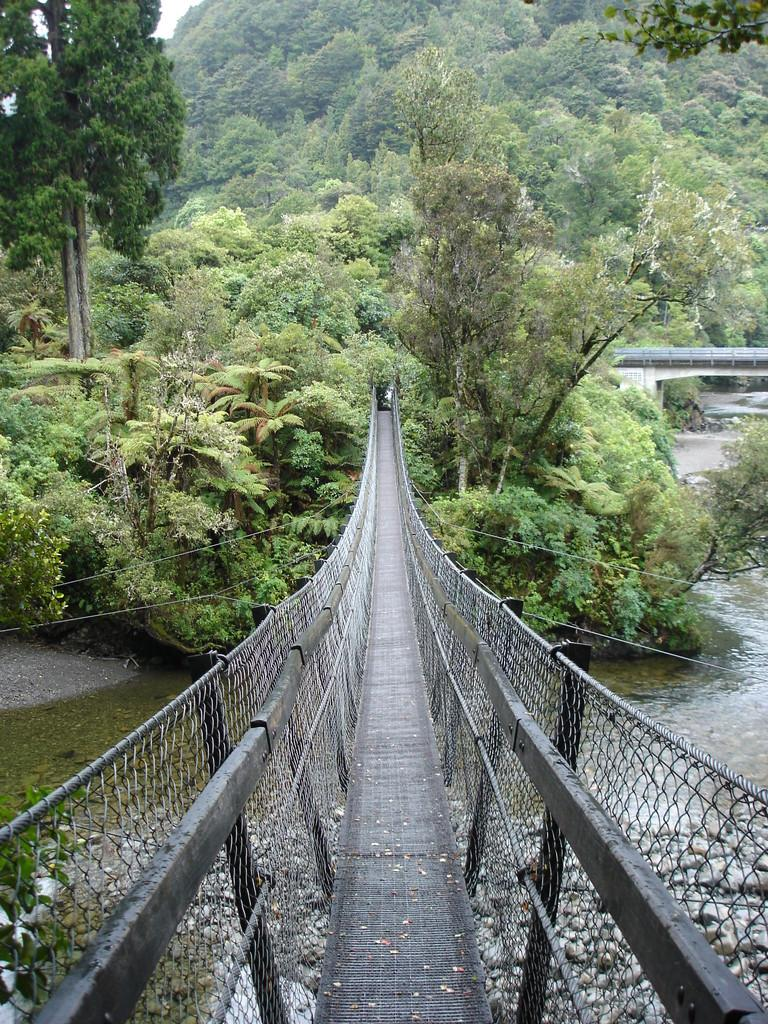What type of natural elements can be seen in the image? There are trees in the image. What type of structure is present in the image? There is a bridge in the image. What body of water can be seen in the image? There is water visible in the image. How many clocks are hanging on the trees in the image? There are no clocks present in the image; it features trees, a bridge, and water. What type of gardening tool is being used by the trees in the image? There are no gardening tools, such as a rake, present in the image. 